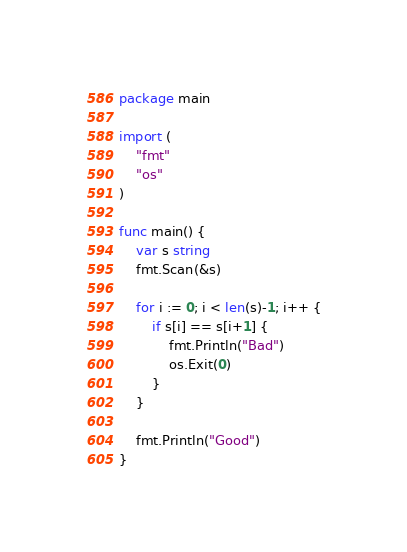Convert code to text. <code><loc_0><loc_0><loc_500><loc_500><_Go_>package main

import (
	"fmt"
	"os"
)

func main() {
	var s string
	fmt.Scan(&s)

	for i := 0; i < len(s)-1; i++ {
		if s[i] == s[i+1] {
			fmt.Println("Bad")
			os.Exit(0)
		}
	}

	fmt.Println("Good")
}
</code> 